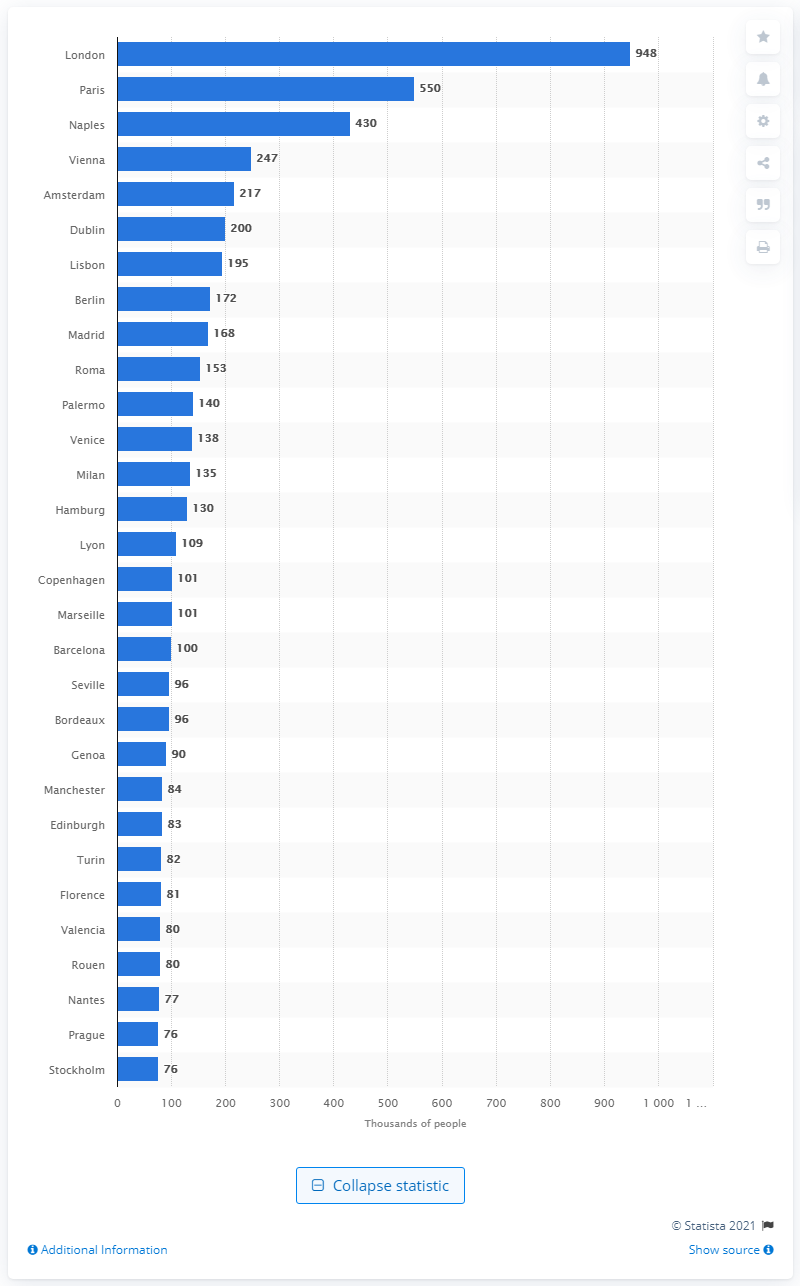What was the largest city in Western Europe in 1800? In 1800, the largest city in Western Europe was London. During that time, it was the burgeoning capital of the British Empire, a hub for commerce, finance, and culture, and home to a vast array of socioeconomic classes. It was an era marked by the Industrial Revolution, which contributed significantly to the city's expansion and population growth. 